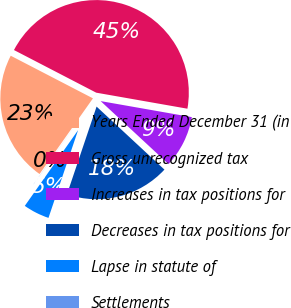Convert chart to OTSL. <chart><loc_0><loc_0><loc_500><loc_500><pie_chart><fcel>Years Ended December 31 (in<fcel>Gross unrecognized tax<fcel>Increases in tax positions for<fcel>Decreases in tax positions for<fcel>Lapse in statute of<fcel>Settlements<nl><fcel>22.83%<fcel>45.16%<fcel>9.14%<fcel>18.27%<fcel>4.58%<fcel>0.02%<nl></chart> 